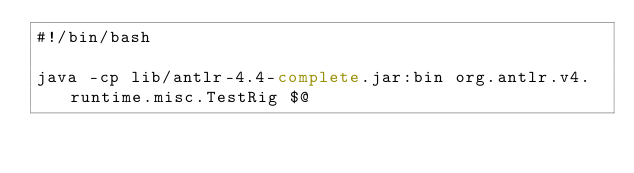<code> <loc_0><loc_0><loc_500><loc_500><_Bash_>#!/bin/bash

java -cp lib/antlr-4.4-complete.jar:bin org.antlr.v4.runtime.misc.TestRig $@
</code> 